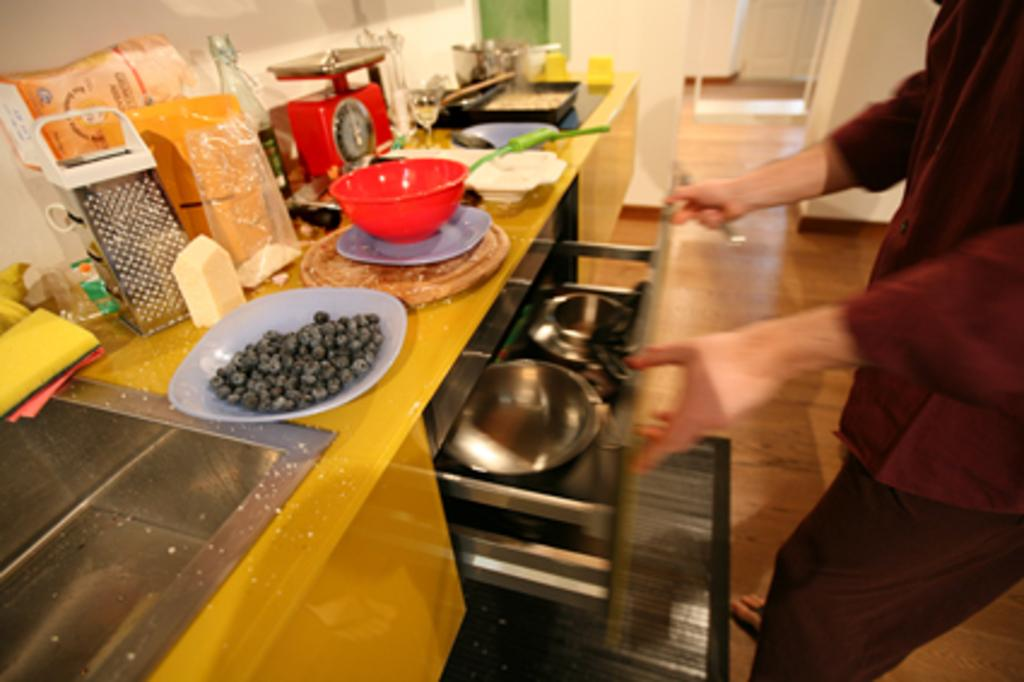What is the person holding in the image? The person is holding a rack in the image. What type of food can be seen on a plate in the image? There is food on a plate in the image. What other dishware is present in the image? There is a bowl and another plate in the image. What is the person likely using to carry the dishes? There is a tray in the image, which the person might be using to carry the dishes. What type of containers are visible in the image? There are vessels in the image. What other objects can be seen on the table in the image? There are other objects on the table in the image. What can be seen in the background of the image? There is a white wall visible in the background of the image. Is the person stuck in quicksand in the image? No, there is no quicksand present in the image. What type of pain is the person experiencing in the image? There is no indication of pain in the image. 